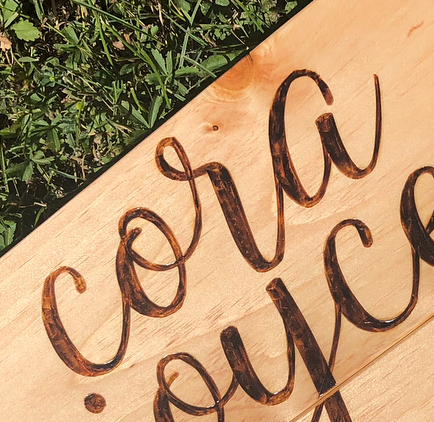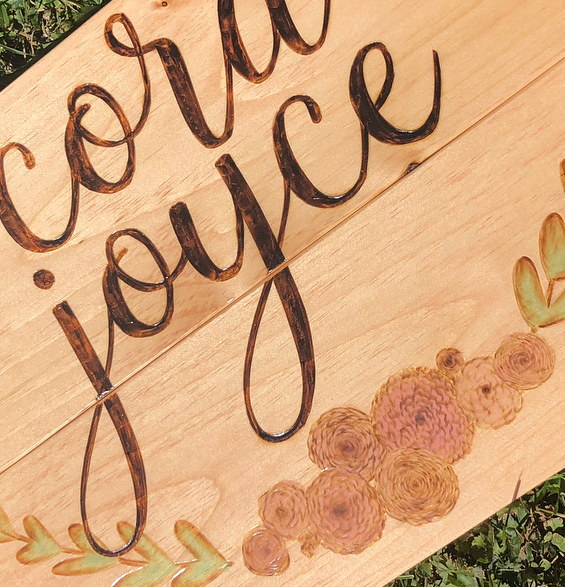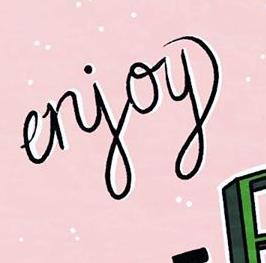What words can you see in these images in sequence, separated by a semicolon? cora; joyce; erjoy 